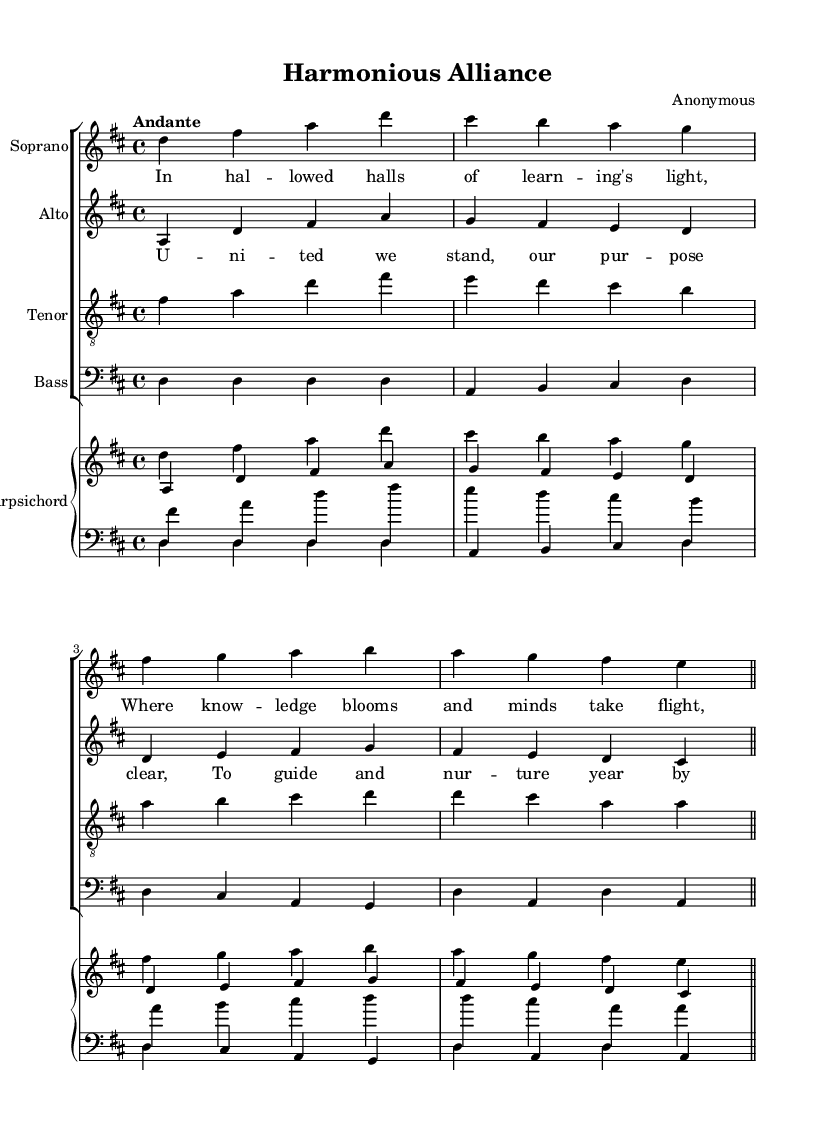What is the key signature of this music? The key signature is indicated by the sharp symbols at the beginning of the staff. The presence of two sharps (F# and C#) identifies the key as D major.
Answer: D major What is the time signature of the piece? The time signature is shown at the beginning of the score, represented as a fraction. Here, it is 4/4, which indicates four beats per measure.
Answer: 4/4 What is the tempo marking indicated for this piece? The tempo is typically provided above the staff; in this case, it is marked as "Andante," which suggests a moderately slow tempo.
Answer: Andante What type of musical work is this? Based on the layout and components of the score, which includes a choir and a harpsichord, this is identified as a choral work.
Answer: Choral work How many vocal parts are present in the score? Counting the distinct voices listed, there are four: soprano, alto, tenor, and bass, which indicates it is a four-part choir arrangement.
Answer: Four What is the primary theme of the lyrics in the first verse? The lyrics convey a message about learning and knowledge, emphasizing the importance of education and enlightenment in a collaborative environment.
Answer: Learning and knowledge 